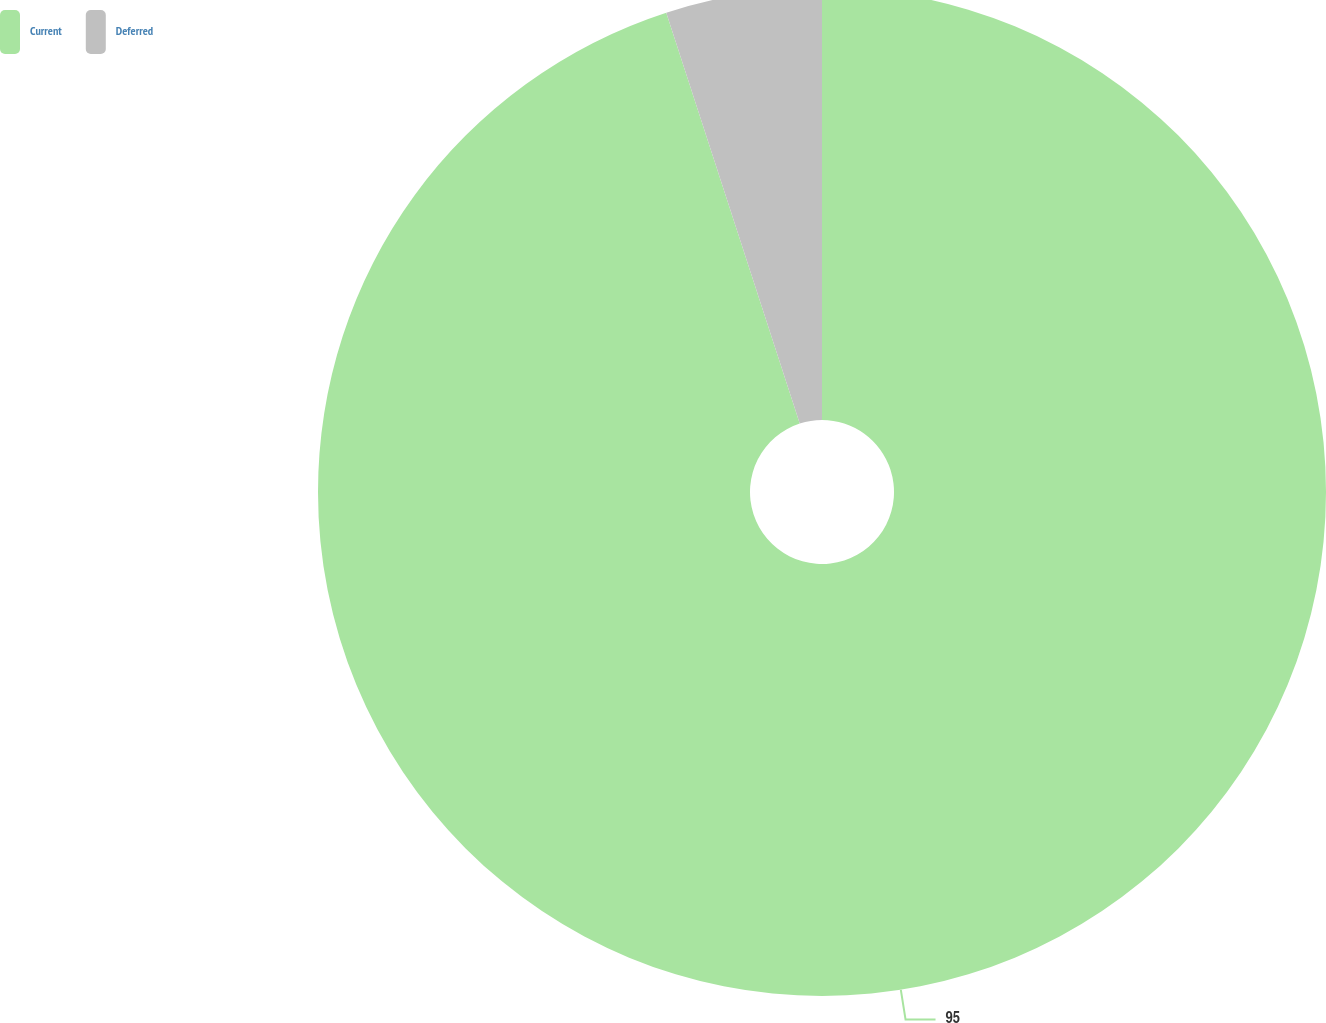Convert chart to OTSL. <chart><loc_0><loc_0><loc_500><loc_500><pie_chart><fcel>Current<fcel>Deferred<nl><fcel>95.0%<fcel>5.0%<nl></chart> 